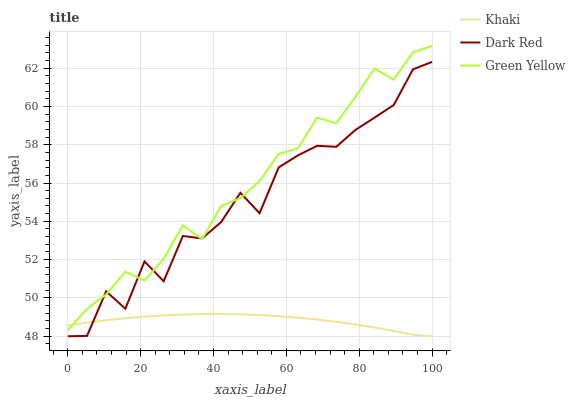Does Green Yellow have the minimum area under the curve?
Answer yes or no. No. Does Khaki have the maximum area under the curve?
Answer yes or no. No. Is Green Yellow the smoothest?
Answer yes or no. No. Is Green Yellow the roughest?
Answer yes or no. No. Does Green Yellow have the lowest value?
Answer yes or no. No. Does Khaki have the highest value?
Answer yes or no. No. 